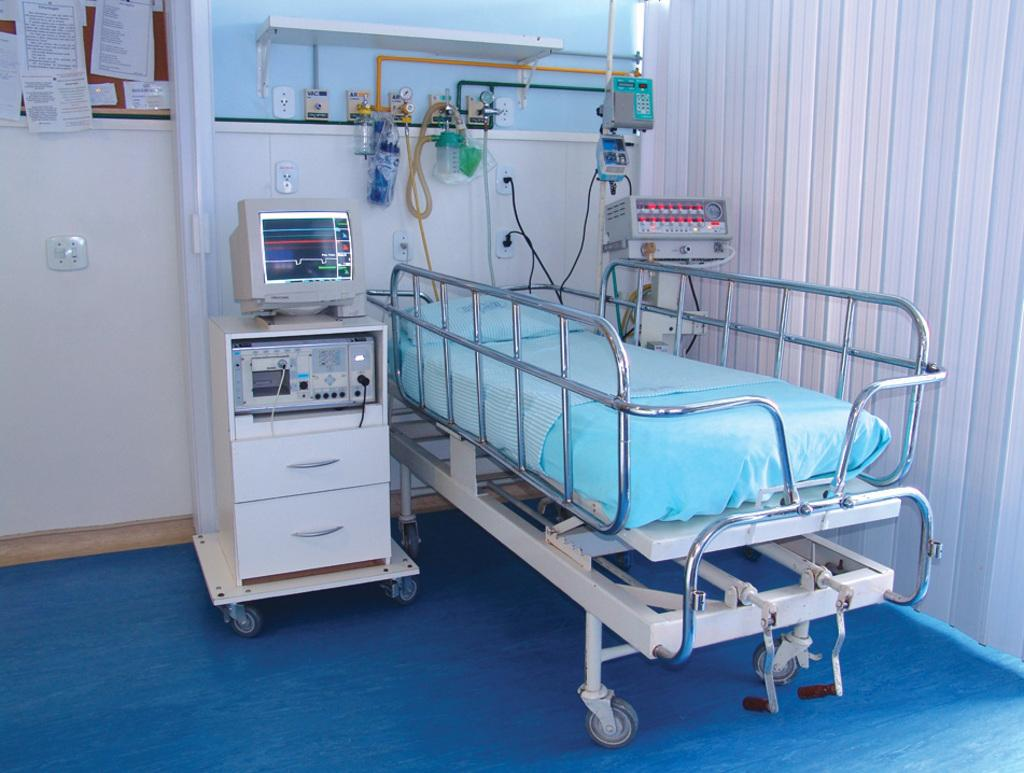What type of furniture is in the image? There is a bed in the image. What material is used for the rods in the image? The rods in the image are made of metal. What electronic device is beside the bed? A monitor is present beside the bed. What type of equipment is in the image that is related to healthcare? There are medical equipment in the image. What type of window covering is visible in the image? Window blinds are visible in the image. What type of sack is being used to transport the wheel in the image? There is no sack or wheel present in the image. 